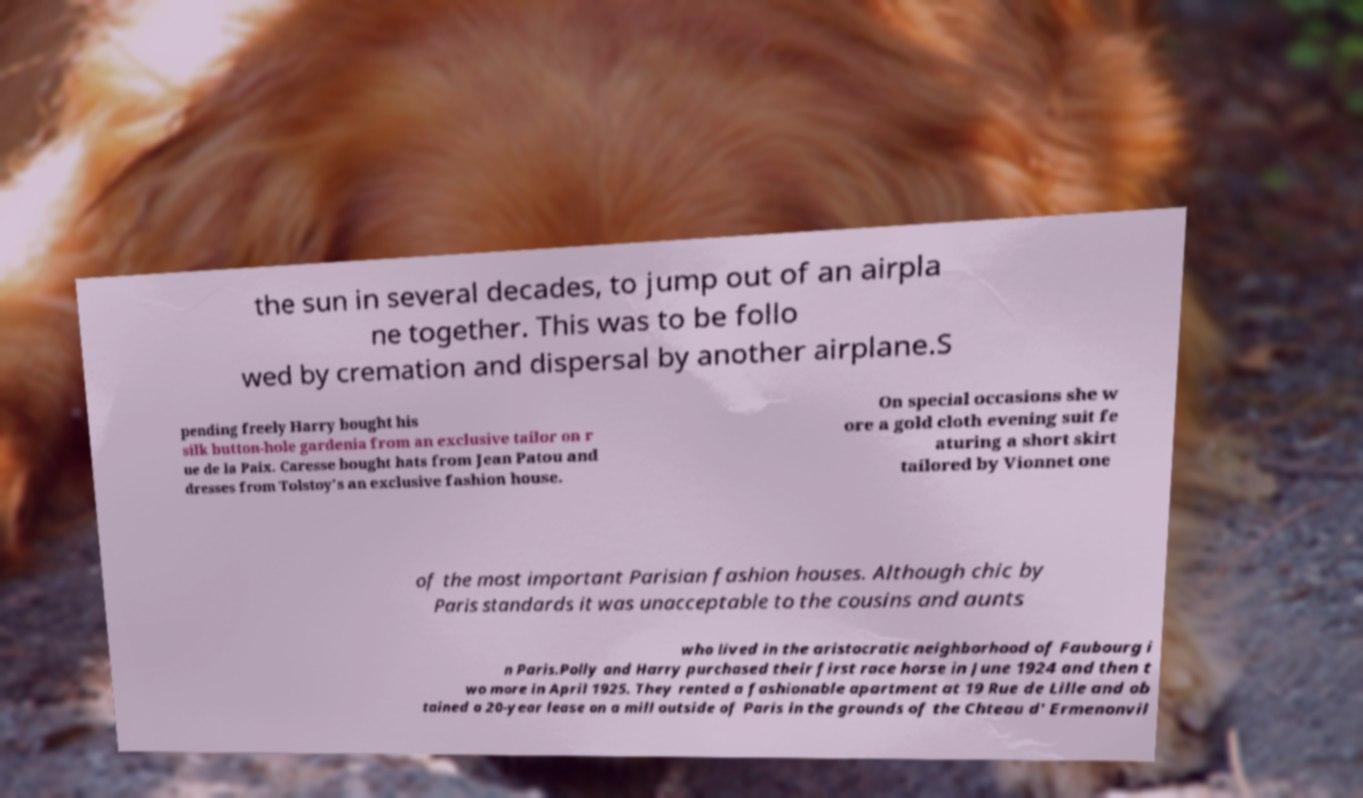Could you extract and type out the text from this image? the sun in several decades, to jump out of an airpla ne together. This was to be follo wed by cremation and dispersal by another airplane.S pending freely Harry bought his silk button-hole gardenia from an exclusive tailor on r ue de la Paix. Caresse bought hats from Jean Patou and dresses from Tolstoy's an exclusive fashion house. On special occasions she w ore a gold cloth evening suit fe aturing a short skirt tailored by Vionnet one of the most important Parisian fashion houses. Although chic by Paris standards it was unacceptable to the cousins and aunts who lived in the aristocratic neighborhood of Faubourg i n Paris.Polly and Harry purchased their first race horse in June 1924 and then t wo more in April 1925. They rented a fashionable apartment at 19 Rue de Lille and ob tained a 20-year lease on a mill outside of Paris in the grounds of the Chteau d' Ermenonvil 